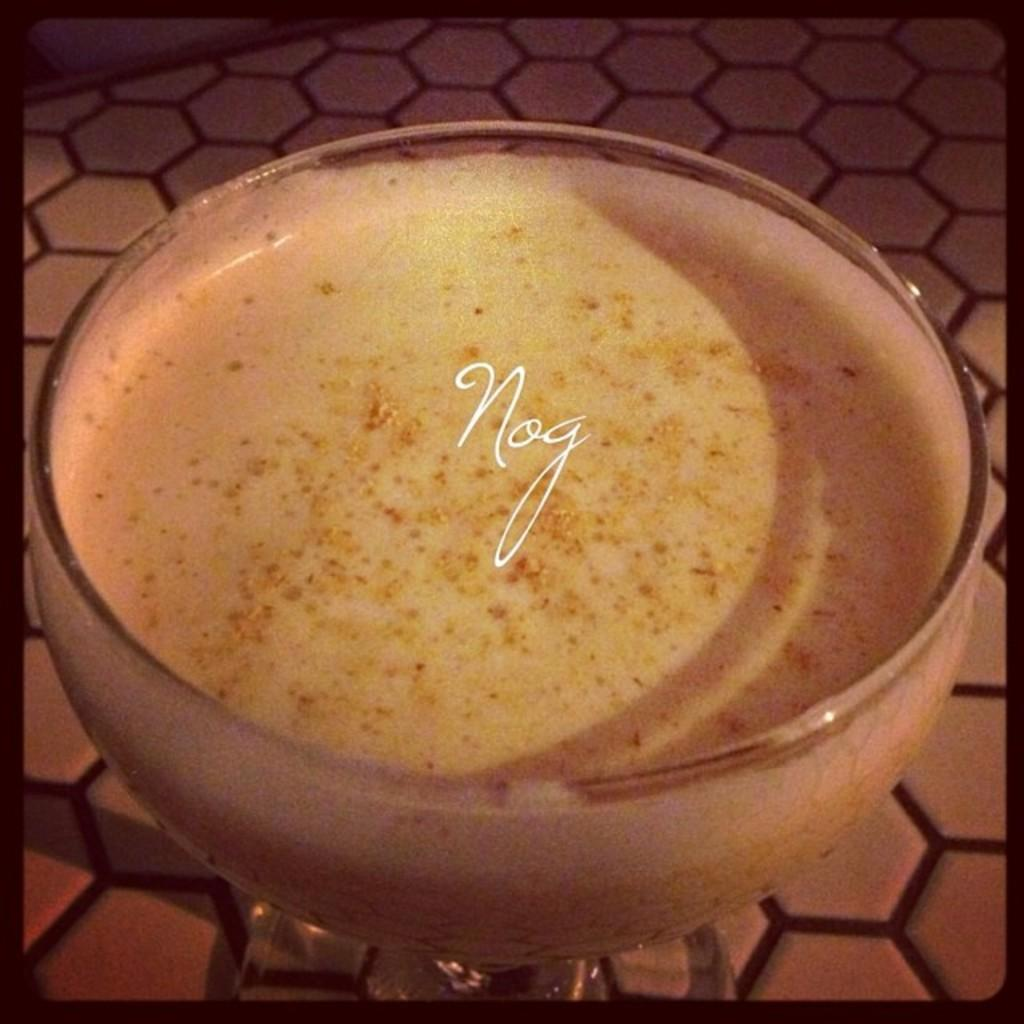What type of cup is in the image? There is a desert cup in the image. What is inside the desert cup? There is a sweet in the desert cup. What word is written on the cup? A: The word "Nog" is written on the cup. What type of rhythm can be heard in the image? There is no audible rhythm present in the image, as it is a static visual representation. 